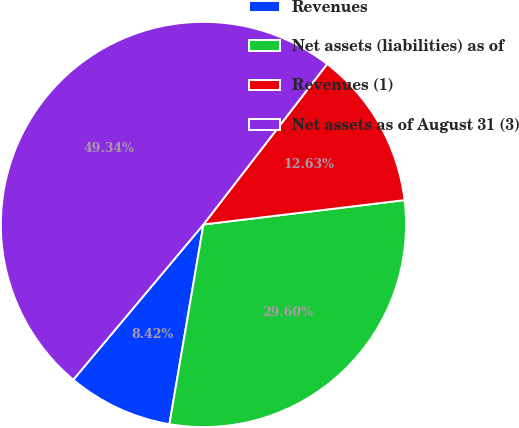Convert chart. <chart><loc_0><loc_0><loc_500><loc_500><pie_chart><fcel>Revenues<fcel>Net assets (liabilities) as of<fcel>Revenues (1)<fcel>Net assets as of August 31 (3)<nl><fcel>8.42%<fcel>29.6%<fcel>12.63%<fcel>49.34%<nl></chart> 